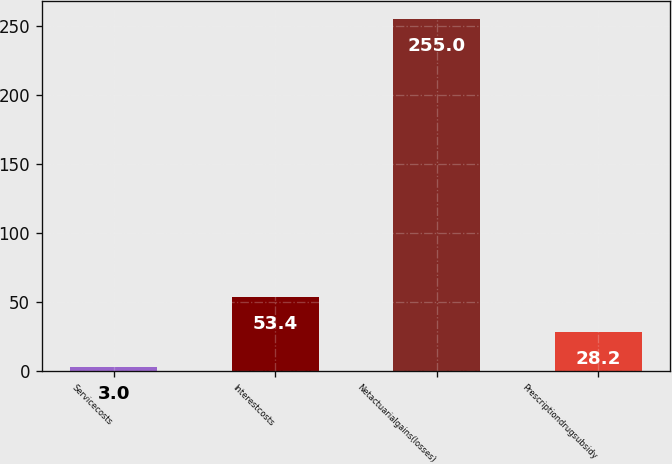Convert chart. <chart><loc_0><loc_0><loc_500><loc_500><bar_chart><fcel>Servicecosts<fcel>Interestcosts<fcel>Netactuarialgains(losses)<fcel>Prescriptiondrugsubsidy<nl><fcel>3<fcel>53.4<fcel>255<fcel>28.2<nl></chart> 